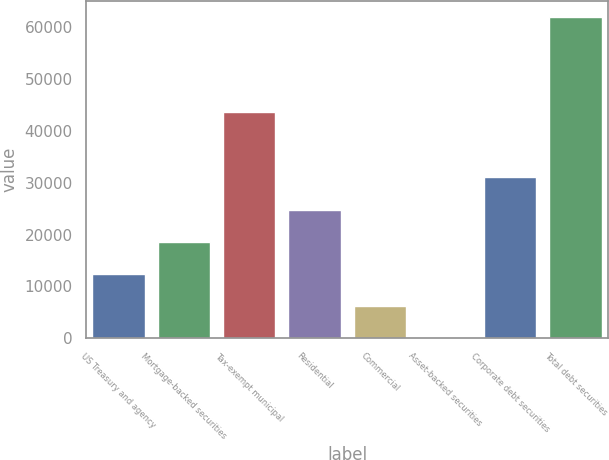Convert chart. <chart><loc_0><loc_0><loc_500><loc_500><bar_chart><fcel>US Treasury and agency<fcel>Mortgage-backed securities<fcel>Tax-exempt municipal<fcel>Residential<fcel>Commercial<fcel>Asset-backed securities<fcel>Corporate debt securities<fcel>Total debt securities<nl><fcel>12436.6<fcel>18632.9<fcel>43619<fcel>24829.2<fcel>6240.3<fcel>44<fcel>31025.5<fcel>62007<nl></chart> 